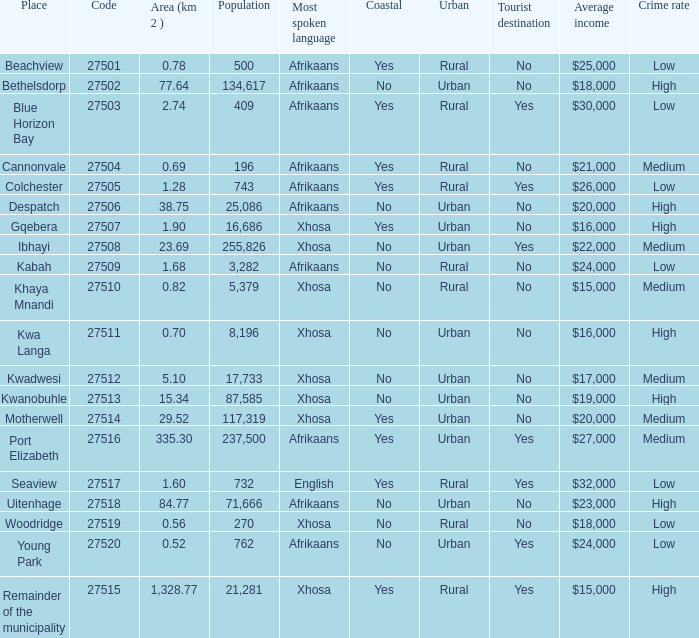What is the lowest area for cannonvale that speaks afrikaans? 0.69. 